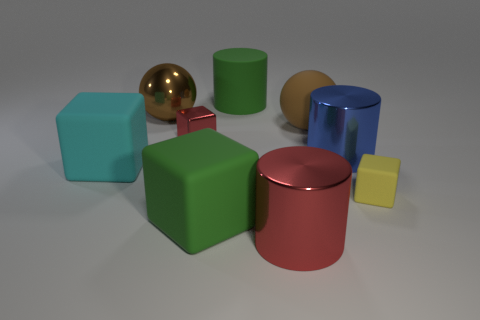Subtract all red blocks. How many blocks are left? 3 Subtract all big cyan blocks. How many blocks are left? 3 Subtract all cubes. How many objects are left? 5 Subtract 1 spheres. How many spheres are left? 1 Add 9 green cubes. How many green cubes are left? 10 Add 6 small green matte cylinders. How many small green matte cylinders exist? 6 Subtract 1 blue cylinders. How many objects are left? 8 Subtract all blue cubes. Subtract all green cylinders. How many cubes are left? 4 Subtract all purple cubes. How many red spheres are left? 0 Subtract all red blocks. Subtract all red metallic blocks. How many objects are left? 7 